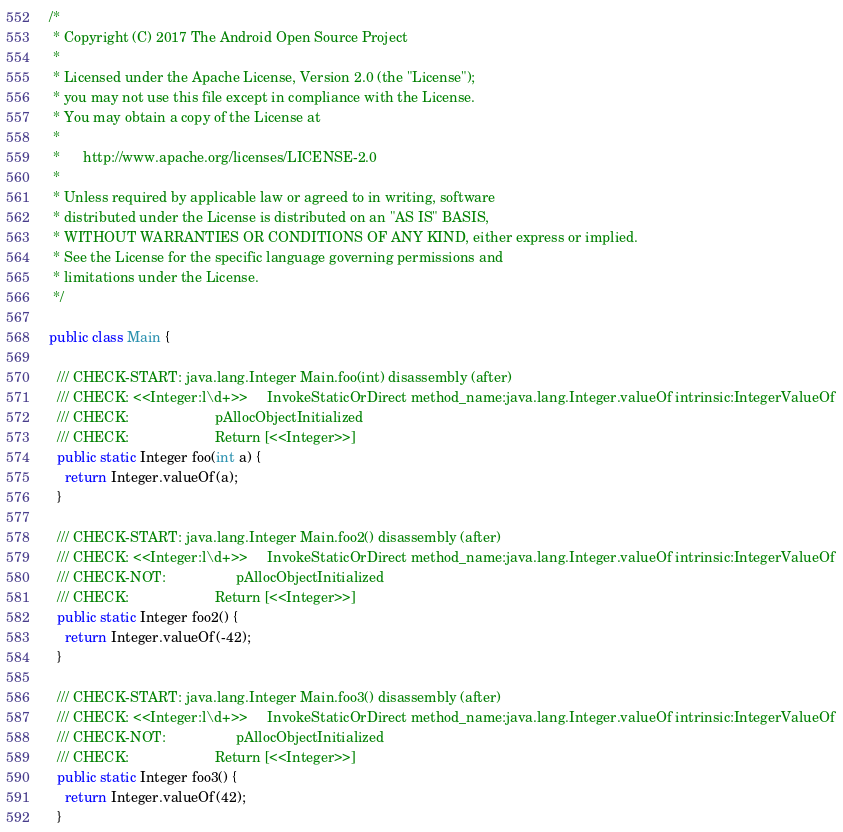<code> <loc_0><loc_0><loc_500><loc_500><_Java_>/*
 * Copyright (C) 2017 The Android Open Source Project
 *
 * Licensed under the Apache License, Version 2.0 (the "License");
 * you may not use this file except in compliance with the License.
 * You may obtain a copy of the License at
 *
 *      http://www.apache.org/licenses/LICENSE-2.0
 *
 * Unless required by applicable law or agreed to in writing, software
 * distributed under the License is distributed on an "AS IS" BASIS,
 * WITHOUT WARRANTIES OR CONDITIONS OF ANY KIND, either express or implied.
 * See the License for the specific language governing permissions and
 * limitations under the License.
 */

public class Main {

  /// CHECK-START: java.lang.Integer Main.foo(int) disassembly (after)
  /// CHECK: <<Integer:l\d+>>     InvokeStaticOrDirect method_name:java.lang.Integer.valueOf intrinsic:IntegerValueOf
  /// CHECK:                      pAllocObjectInitialized
  /// CHECK:                      Return [<<Integer>>]
  public static Integer foo(int a) {
    return Integer.valueOf(a);
  }

  /// CHECK-START: java.lang.Integer Main.foo2() disassembly (after)
  /// CHECK: <<Integer:l\d+>>     InvokeStaticOrDirect method_name:java.lang.Integer.valueOf intrinsic:IntegerValueOf
  /// CHECK-NOT:                  pAllocObjectInitialized
  /// CHECK:                      Return [<<Integer>>]
  public static Integer foo2() {
    return Integer.valueOf(-42);
  }

  /// CHECK-START: java.lang.Integer Main.foo3() disassembly (after)
  /// CHECK: <<Integer:l\d+>>     InvokeStaticOrDirect method_name:java.lang.Integer.valueOf intrinsic:IntegerValueOf
  /// CHECK-NOT:                  pAllocObjectInitialized
  /// CHECK:                      Return [<<Integer>>]
  public static Integer foo3() {
    return Integer.valueOf(42);
  }
</code> 